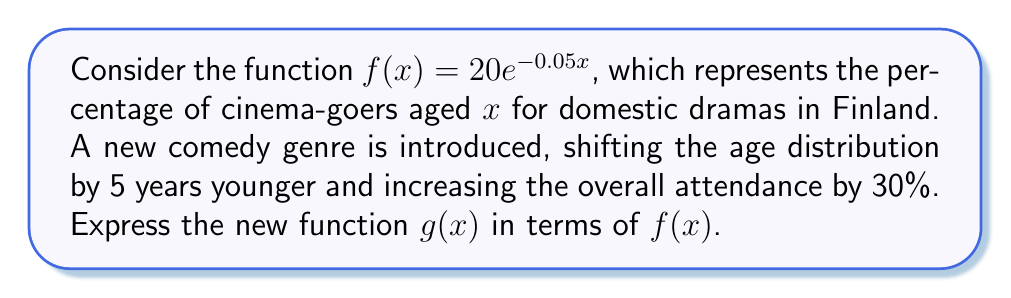Provide a solution to this math problem. To solve this problem, we need to apply two transformations to the original function $f(x)$:

1. Horizontal shift: The age distribution is shifted 5 years younger, which means we replace $x$ with $(x+5)$ in the function.

2. Vertical stretch: The overall attendance is increased by 30%, which means we multiply the function by 1.3.

Let's apply these transformations step by step:

Step 1: Horizontal shift
$f(x+5) = 20e^{-0.05(x+5)}$

Step 2: Vertical stretch
$g(x) = 1.3 \cdot f(x+5)$

Step 3: Combine the transformations
$g(x) = 1.3 \cdot 20e^{-0.05(x+5)}$

Step 4: Simplify
$g(x) = 26e^{-0.05(x+5)}$

Therefore, the new function $g(x)$ can be expressed in terms of $f(x)$ as:
$g(x) = 1.3 \cdot f(x+5)$
Answer: $g(x) = 1.3 \cdot f(x+5)$ 